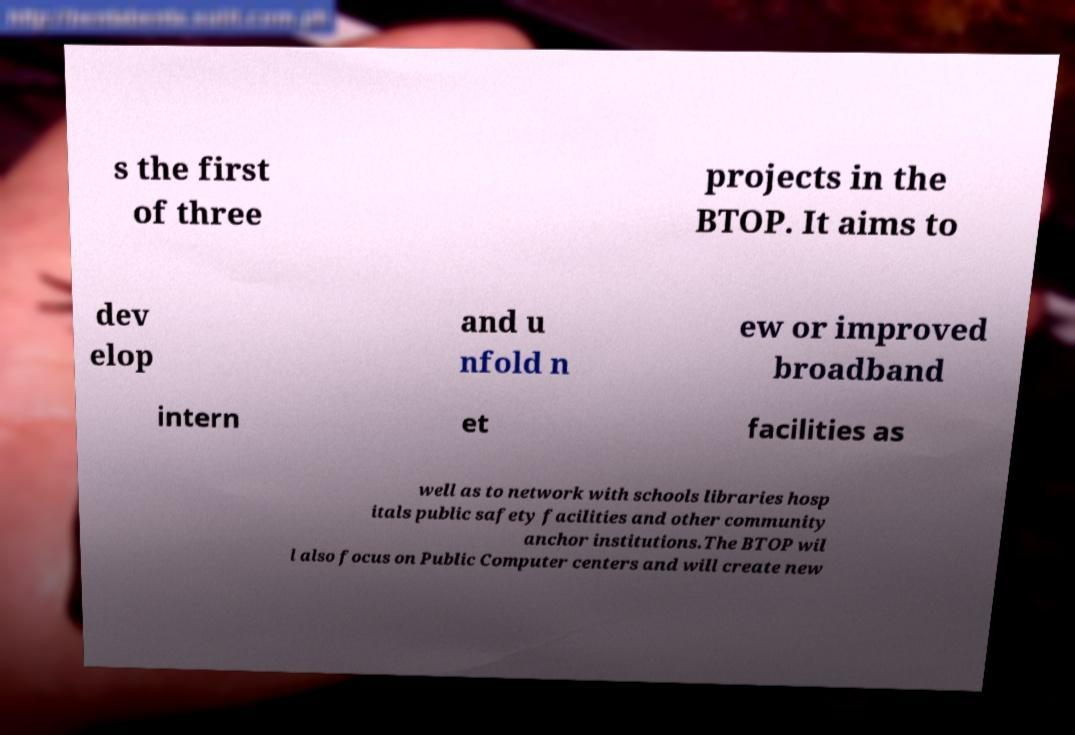Please identify and transcribe the text found in this image. s the first of three projects in the BTOP. It aims to dev elop and u nfold n ew or improved broadband intern et facilities as well as to network with schools libraries hosp itals public safety facilities and other community anchor institutions.The BTOP wil l also focus on Public Computer centers and will create new 